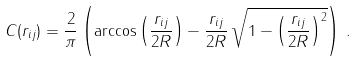Convert formula to latex. <formula><loc_0><loc_0><loc_500><loc_500>C ( r _ { i j } ) = \frac { 2 } { \pi } \left ( \arccos \left ( \frac { r _ { i j } } { 2 R } \right ) - \frac { r _ { i j } } { 2 R } \, \sqrt { 1 - \left ( \frac { r _ { i j } } { 2 R } \right ) ^ { 2 } } \right ) \, .</formula> 